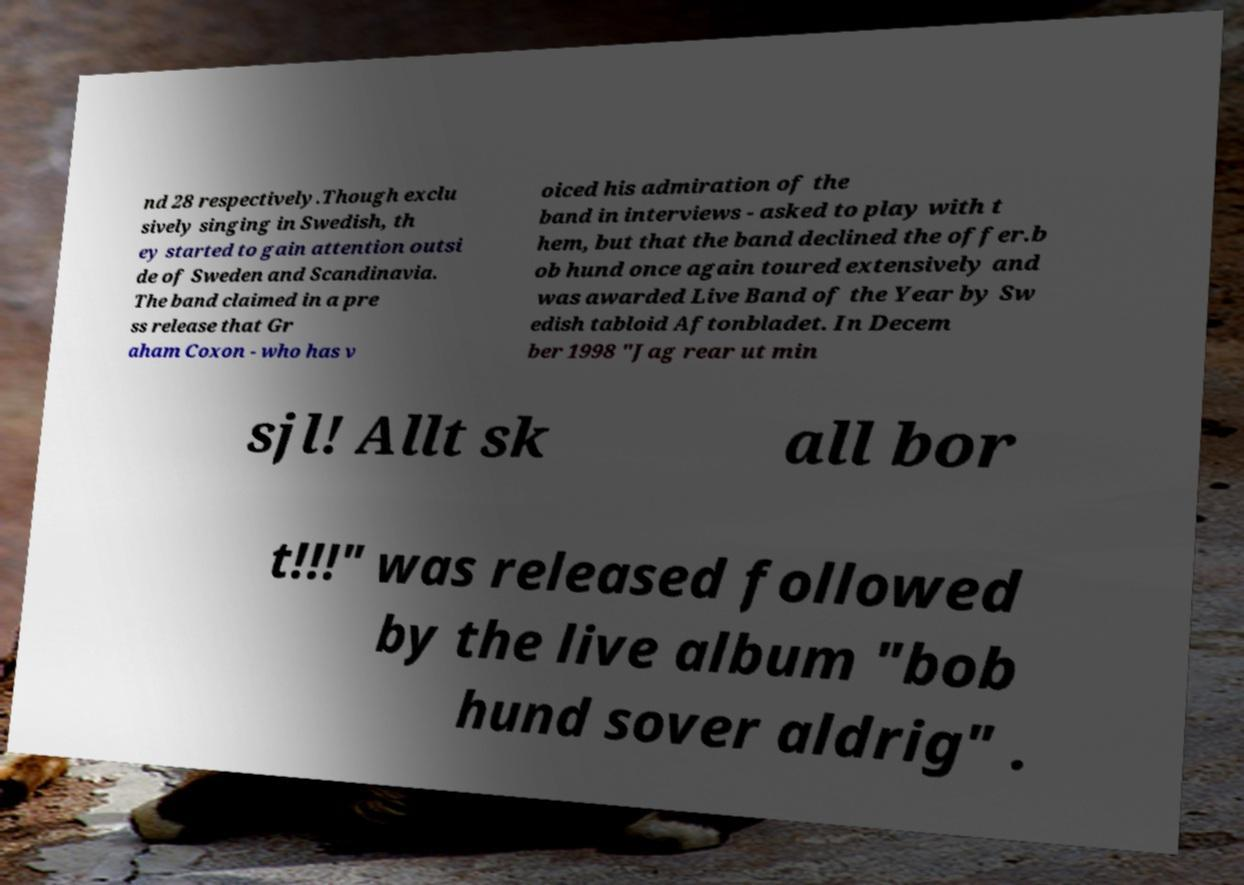Can you read and provide the text displayed in the image?This photo seems to have some interesting text. Can you extract and type it out for me? nd 28 respectively.Though exclu sively singing in Swedish, th ey started to gain attention outsi de of Sweden and Scandinavia. The band claimed in a pre ss release that Gr aham Coxon - who has v oiced his admiration of the band in interviews - asked to play with t hem, but that the band declined the offer.b ob hund once again toured extensively and was awarded Live Band of the Year by Sw edish tabloid Aftonbladet. In Decem ber 1998 "Jag rear ut min sjl! Allt sk all bor t!!!" was released followed by the live album "bob hund sover aldrig" . 